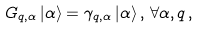<formula> <loc_0><loc_0><loc_500><loc_500>G _ { q , \alpha } \left | \alpha \right \rangle = \gamma _ { q , \alpha } \left | \alpha \right \rangle , \, \forall \alpha , q \, ,</formula> 